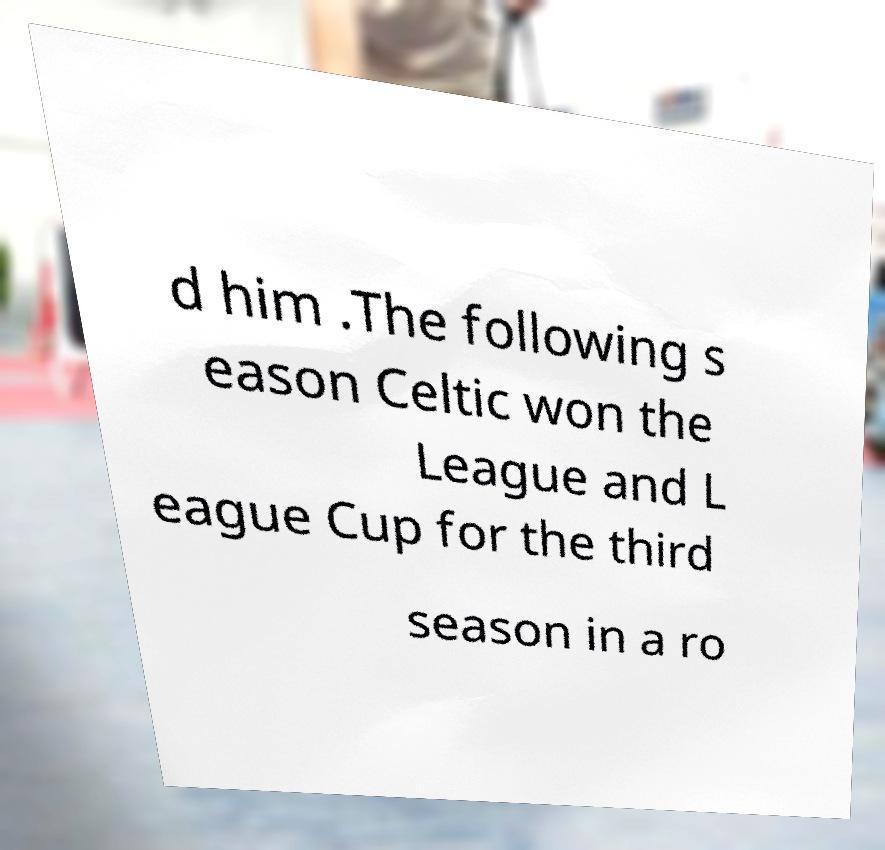Could you extract and type out the text from this image? d him .The following s eason Celtic won the League and L eague Cup for the third season in a ro 